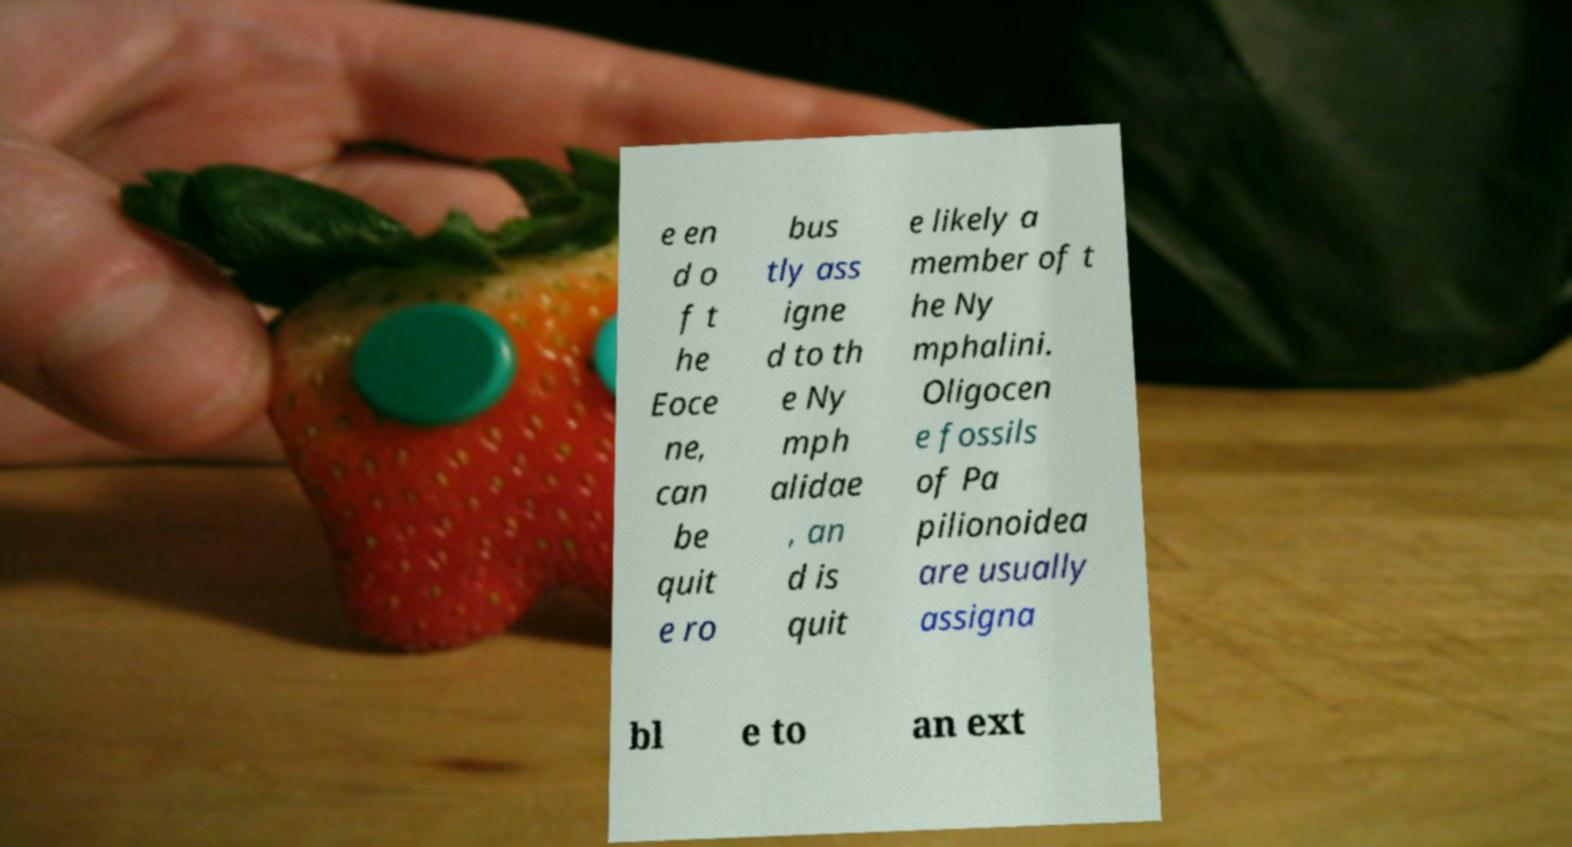Could you assist in decoding the text presented in this image and type it out clearly? e en d o f t he Eoce ne, can be quit e ro bus tly ass igne d to th e Ny mph alidae , an d is quit e likely a member of t he Ny mphalini. Oligocen e fossils of Pa pilionoidea are usually assigna bl e to an ext 